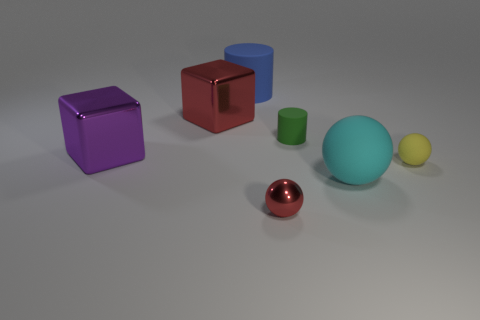Subtract all small balls. How many balls are left? 1 Add 3 metallic balls. How many objects exist? 10 Subtract all cyan balls. How many balls are left? 2 Subtract all blocks. How many objects are left? 5 Subtract 2 balls. How many balls are left? 1 Subtract all yellow cylinders. Subtract all red cubes. How many cylinders are left? 2 Subtract all cyan rubber blocks. Subtract all large red metallic objects. How many objects are left? 6 Add 3 tiny red metal objects. How many tiny red metal objects are left? 4 Add 4 big rubber cylinders. How many big rubber cylinders exist? 5 Subtract 1 red blocks. How many objects are left? 6 